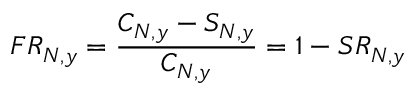<formula> <loc_0><loc_0><loc_500><loc_500>F R _ { N , y } = \frac { C _ { N , y } - S _ { N , y } } { C _ { N , y } } = 1 - S R _ { N , y }</formula> 